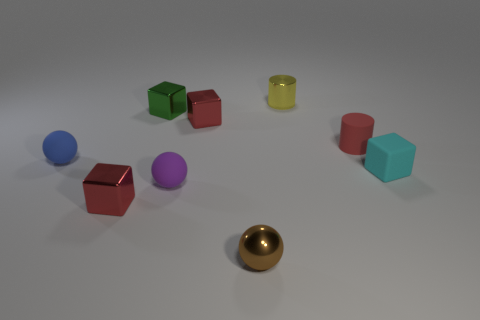Subtract all red blocks. Subtract all blue spheres. How many blocks are left? 2 Add 1 small brown metallic objects. How many objects exist? 10 Subtract all blocks. How many objects are left? 5 Add 7 purple matte objects. How many purple matte objects are left? 8 Add 8 rubber cylinders. How many rubber cylinders exist? 9 Subtract 0 cyan cylinders. How many objects are left? 9 Subtract all yellow shiny blocks. Subtract all green cubes. How many objects are left? 8 